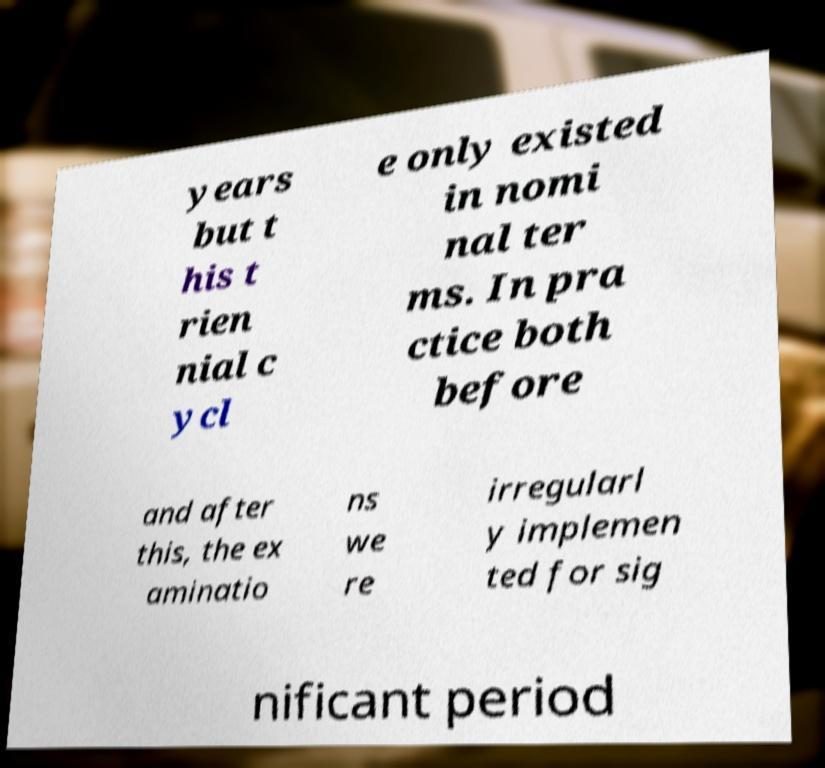Can you accurately transcribe the text from the provided image for me? years but t his t rien nial c ycl e only existed in nomi nal ter ms. In pra ctice both before and after this, the ex aminatio ns we re irregularl y implemen ted for sig nificant period 